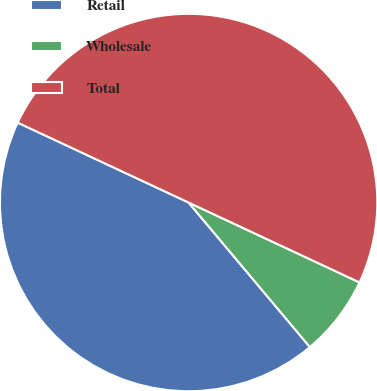Convert chart. <chart><loc_0><loc_0><loc_500><loc_500><pie_chart><fcel>Retail<fcel>Wholesale<fcel>Total<nl><fcel>43.07%<fcel>6.93%<fcel>50.0%<nl></chart> 